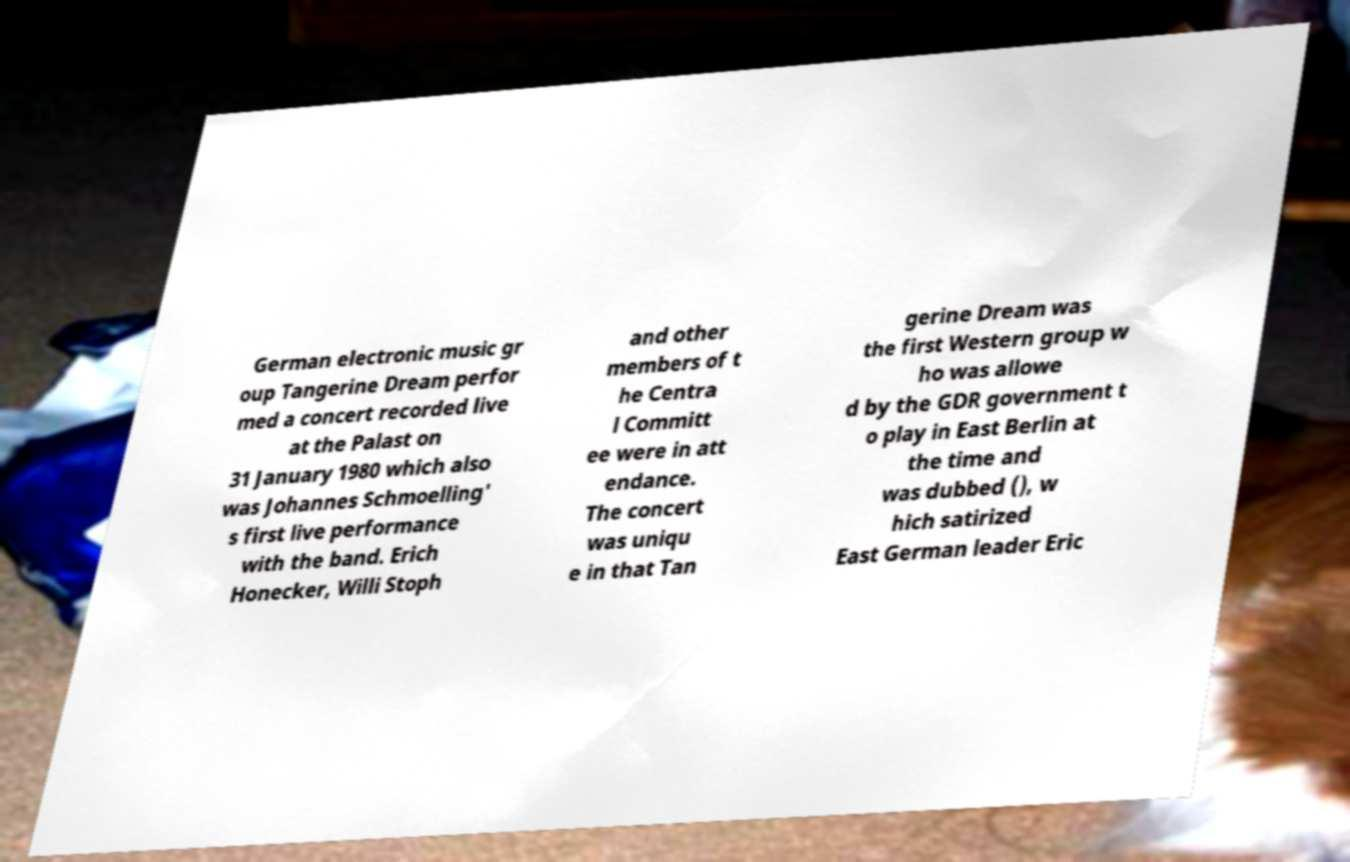Please identify and transcribe the text found in this image. German electronic music gr oup Tangerine Dream perfor med a concert recorded live at the Palast on 31 January 1980 which also was Johannes Schmoelling' s first live performance with the band. Erich Honecker, Willi Stoph and other members of t he Centra l Committ ee were in att endance. The concert was uniqu e in that Tan gerine Dream was the first Western group w ho was allowe d by the GDR government t o play in East Berlin at the time and was dubbed (), w hich satirized East German leader Eric 